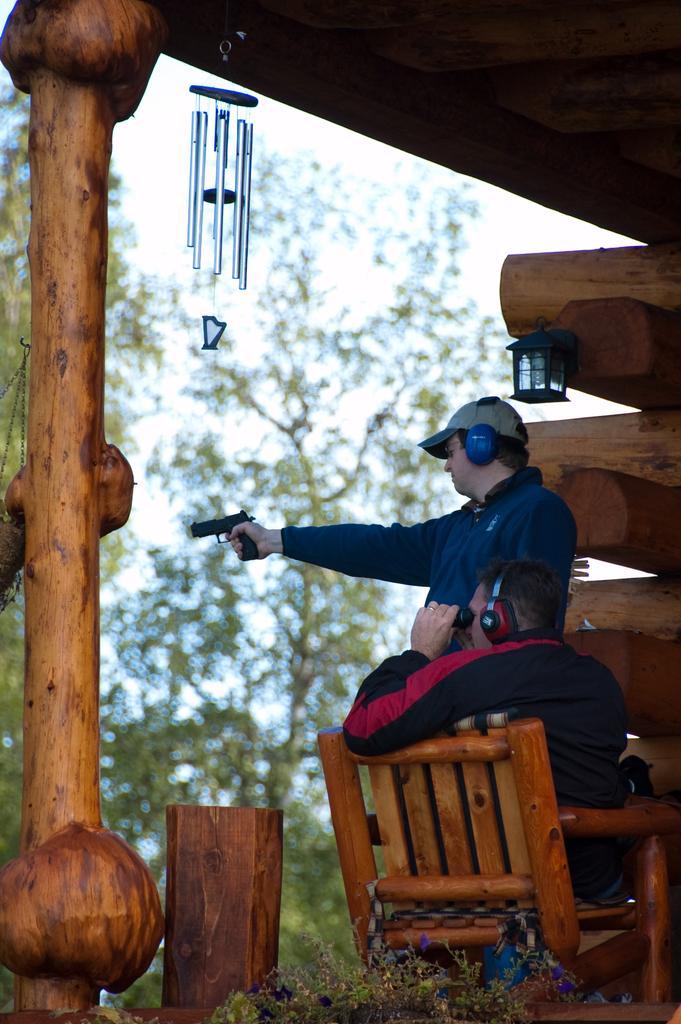Can you describe this image briefly? This is a picture taken in the outdoors. The man in black jacket was sitting on a chair and holding binoculars and the other man in blue jacket with hat holding a gun. Behind the people there are wooden, pole, decorative item, trees and sky. 